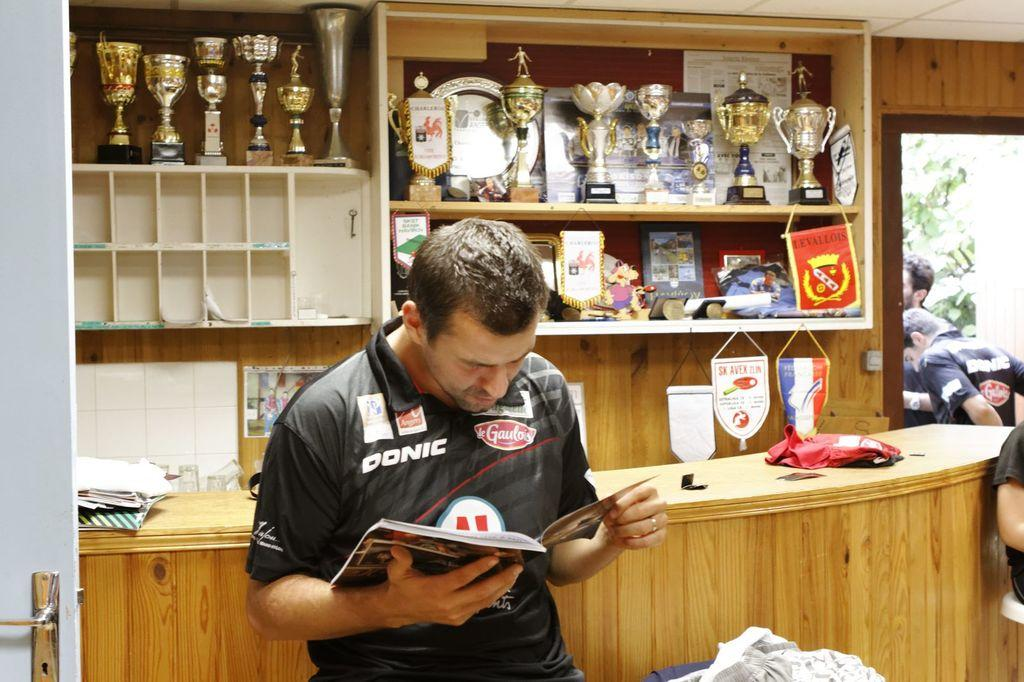<image>
Present a compact description of the photo's key features. A man with a shirt that has the Donis logo is reading a book 